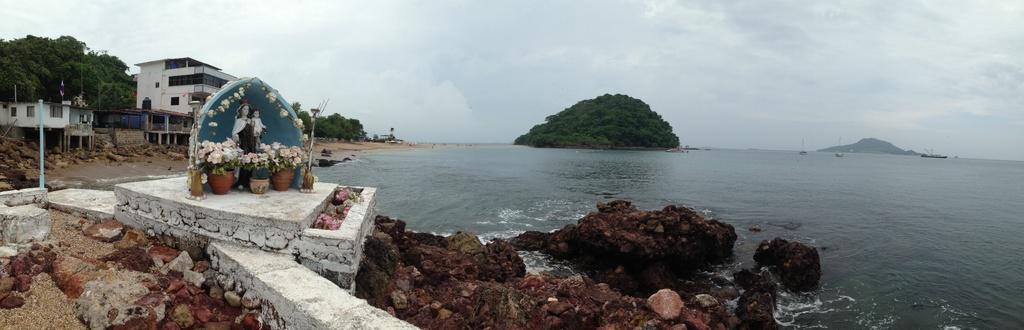Please provide a concise description of this image. In this image we can see water, rocks, statues, plants, flowers, poles, trees, buildings, boats, and mountain. In the background there is sky with clouds. 